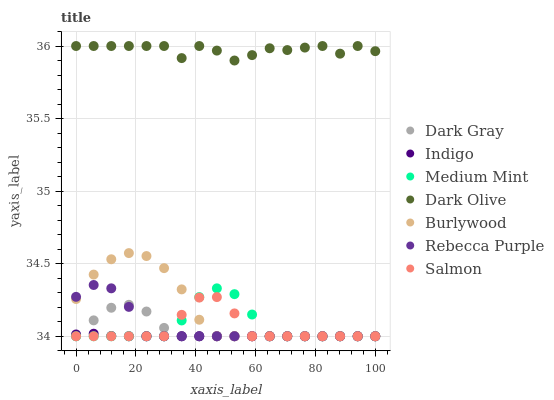Does Indigo have the minimum area under the curve?
Answer yes or no. Yes. Does Dark Olive have the maximum area under the curve?
Answer yes or no. Yes. Does Burlywood have the minimum area under the curve?
Answer yes or no. No. Does Burlywood have the maximum area under the curve?
Answer yes or no. No. Is Indigo the smoothest?
Answer yes or no. Yes. Is Dark Olive the roughest?
Answer yes or no. Yes. Is Burlywood the smoothest?
Answer yes or no. No. Is Burlywood the roughest?
Answer yes or no. No. Does Medium Mint have the lowest value?
Answer yes or no. Yes. Does Dark Olive have the lowest value?
Answer yes or no. No. Does Dark Olive have the highest value?
Answer yes or no. Yes. Does Burlywood have the highest value?
Answer yes or no. No. Is Medium Mint less than Dark Olive?
Answer yes or no. Yes. Is Dark Olive greater than Medium Mint?
Answer yes or no. Yes. Does Medium Mint intersect Indigo?
Answer yes or no. Yes. Is Medium Mint less than Indigo?
Answer yes or no. No. Is Medium Mint greater than Indigo?
Answer yes or no. No. Does Medium Mint intersect Dark Olive?
Answer yes or no. No. 